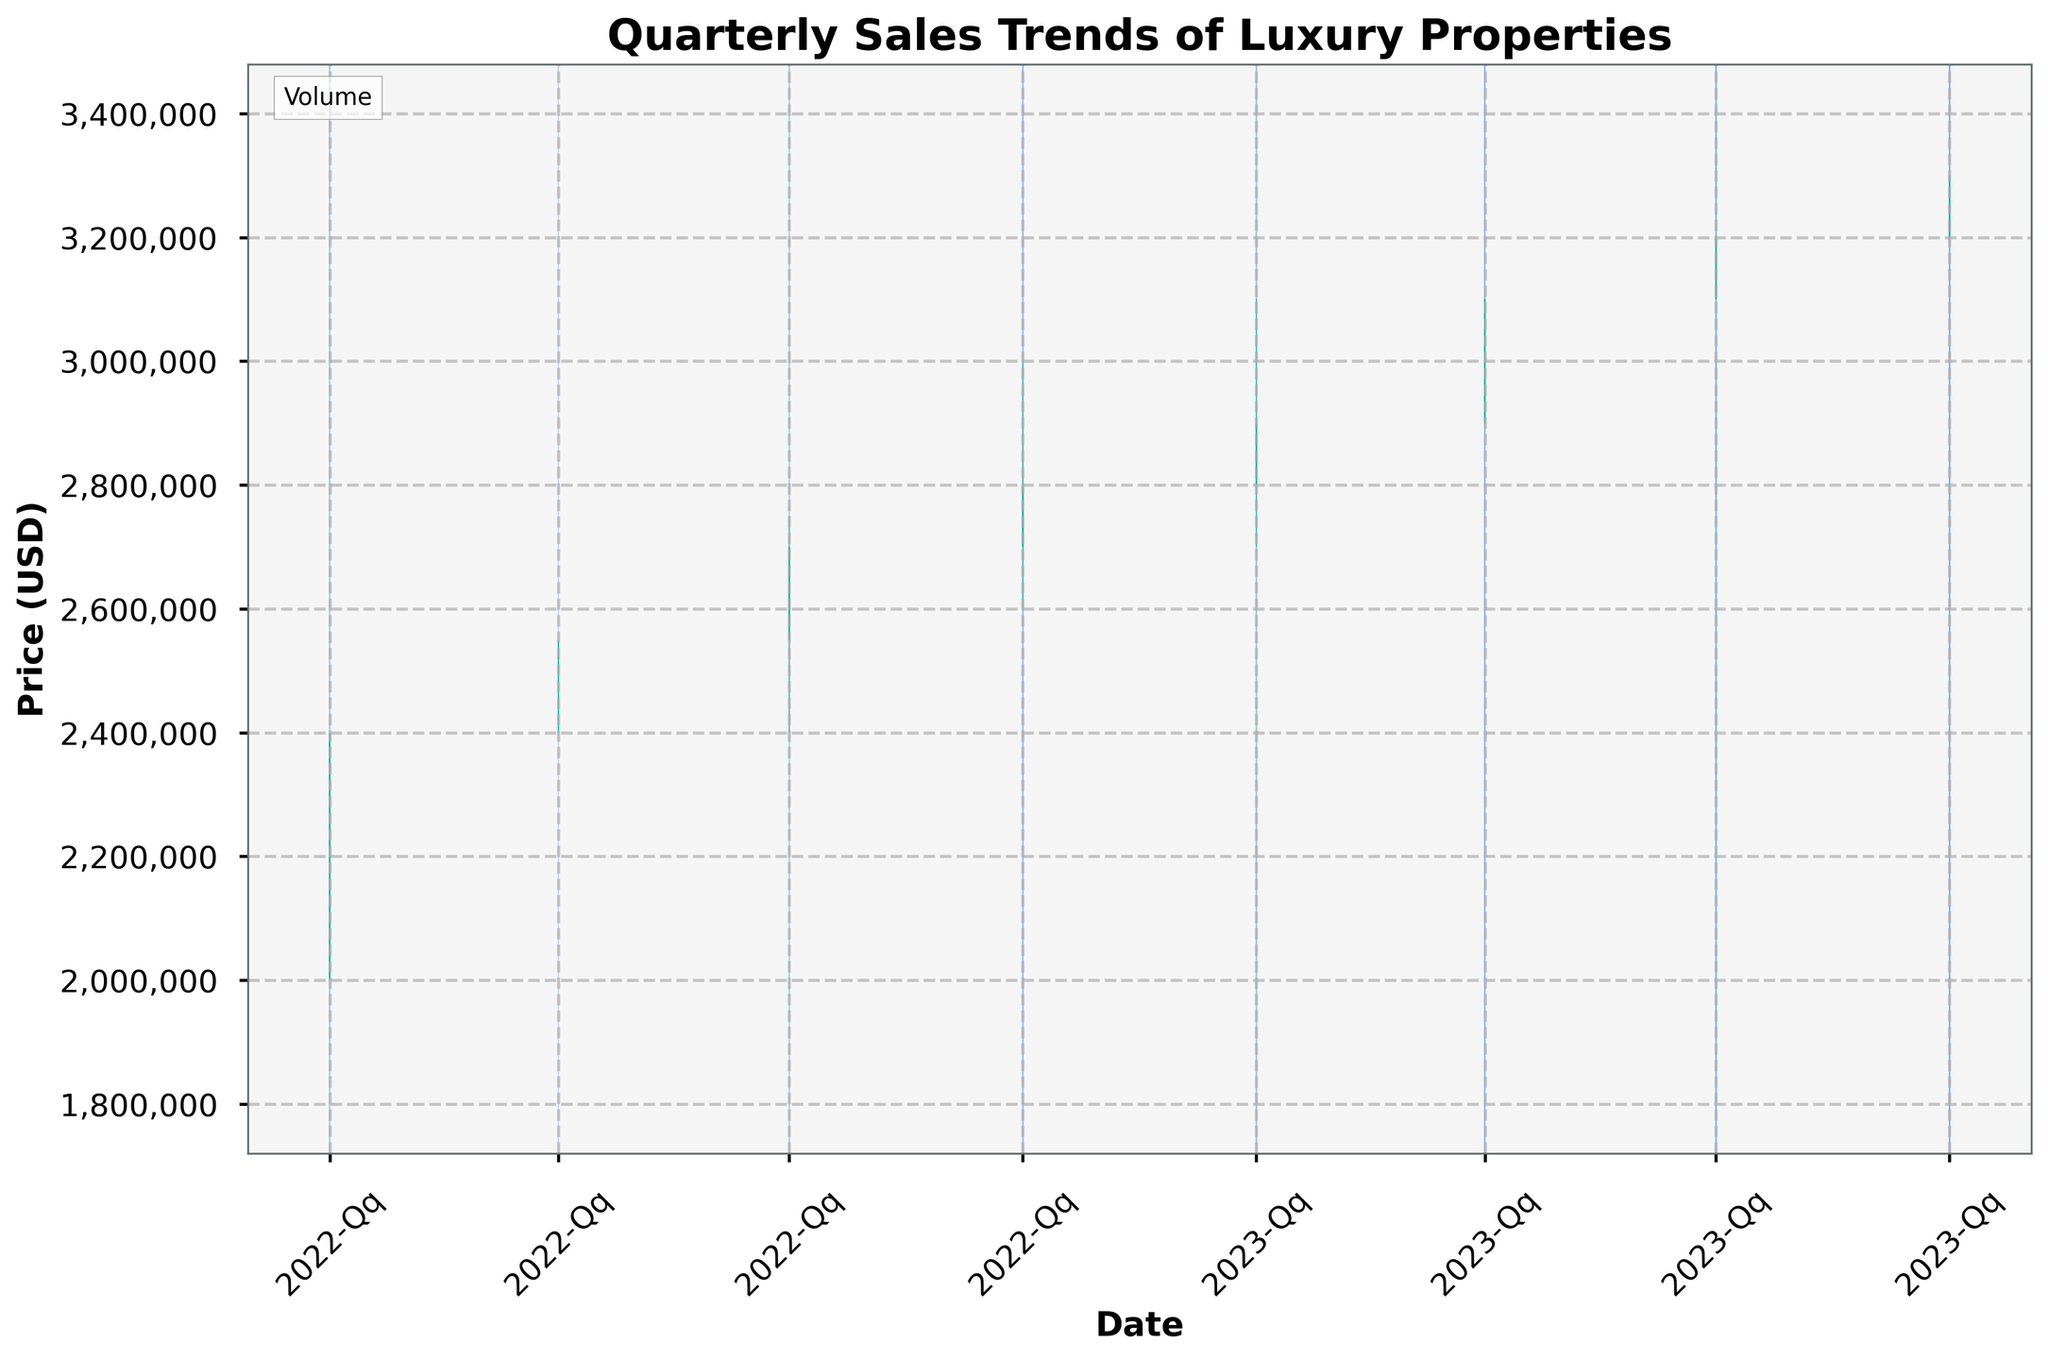What is the title of the figure? The title of the figure can typically be found at the top of the plot. It is clearly labeled to give an overview of what the data represents.
Answer: Quarterly Sales Trends of Luxury Properties Which quarter shows the highest closing price? The closing price is represented by the top of the main bar in the candlestick plot for that quarter. By checking each bar, we can see that the highest closing price is in 2023-Q4.
Answer: 2023-Q4 What are the opening and closing prices in 2022-Q4? The opening price is at the bottom of the main bar and the closing price is at the top. For 2022-Q4, the opening price is 2,700,000 USD, and the closing price is 2,800,000 USD.
Answer: 2,700,000 USD, 2,800,000 USD Between 2023-Q1 and 2023-Q2, how much did the closing price increase? The closing price for 2023-Q1 is 2,900,000 USD and for 2023-Q2 is 3,100,000 USD. The increase is the difference between these two values, which is 200,000 USD.
Answer: 200,000 USD Which quarter had the highest volume of sales? The sales volume can be interpreted from the intensity of the color overlay of the volume bars. The quarter with the darkest blue, representing the highest volume, is 2023-Q4.
Answer: 2023-Q4 How many quarters show a positive trend where the closing price is higher than the opening price? Positive trends are represented by green bars where the closing price is above the opening price. Counting these, we get 6 quarters with green bars.
Answer: 6 In which quarter did the difference between the high and low price reach its maximum? The length of the wick (the thin line above and below the main bar) represents the range between high and low prices. The longest wick is seen in 2023-Q4.
Answer: 2023-Q4 What is the average closing price for the year 2022? The closing prices for each quarter in 2022 are 2,400,000, 2,550,000, 2,700,000, and 2,800,000 USD. Adding these together gives 10,450,000 USD, and dividing by 4 for the average gives 2,612,500 USD.
Answer: 2,612,500 USD Comparing the first quarters of 2022 and 2023, which has a higher closing price and by how much? The closing price for 2022-Q1 is 2,400,000 USD, and for 2023-Q1 is 2,900,000 USD. The difference is 2,900,000 - 2,400,000 = 500,000 USD.
Answer: 2023-Q1, 500,000 USD What was the trend in closing prices from 2022-Q1 to 2022-Q4? Observing the position of the tops of the main bars from the first to the fourth quarter in 2022, we see an upward trend as closing prices increase each quarter from 2,400,000 USD to 2,800,000 USD.
Answer: Upward 